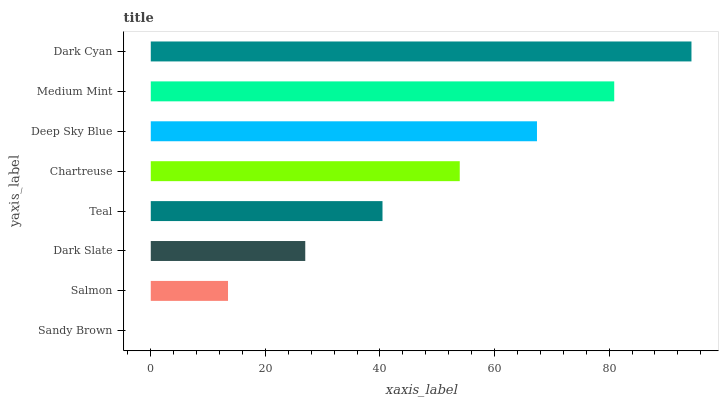Is Sandy Brown the minimum?
Answer yes or no. Yes. Is Dark Cyan the maximum?
Answer yes or no. Yes. Is Salmon the minimum?
Answer yes or no. No. Is Salmon the maximum?
Answer yes or no. No. Is Salmon greater than Sandy Brown?
Answer yes or no. Yes. Is Sandy Brown less than Salmon?
Answer yes or no. Yes. Is Sandy Brown greater than Salmon?
Answer yes or no. No. Is Salmon less than Sandy Brown?
Answer yes or no. No. Is Chartreuse the high median?
Answer yes or no. Yes. Is Teal the low median?
Answer yes or no. Yes. Is Medium Mint the high median?
Answer yes or no. No. Is Dark Cyan the low median?
Answer yes or no. No. 